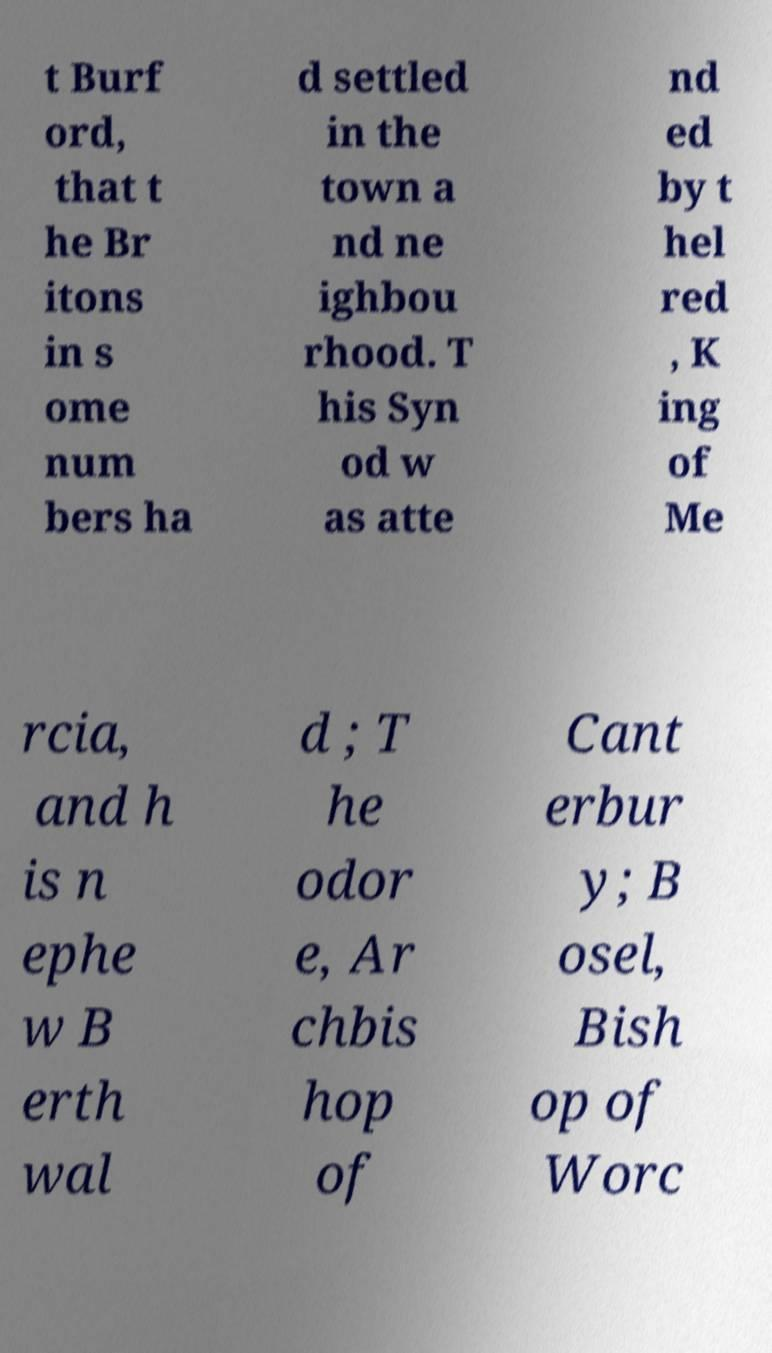There's text embedded in this image that I need extracted. Can you transcribe it verbatim? t Burf ord, that t he Br itons in s ome num bers ha d settled in the town a nd ne ighbou rhood. T his Syn od w as atte nd ed by t hel red , K ing of Me rcia, and h is n ephe w B erth wal d ; T he odor e, Ar chbis hop of Cant erbur y; B osel, Bish op of Worc 